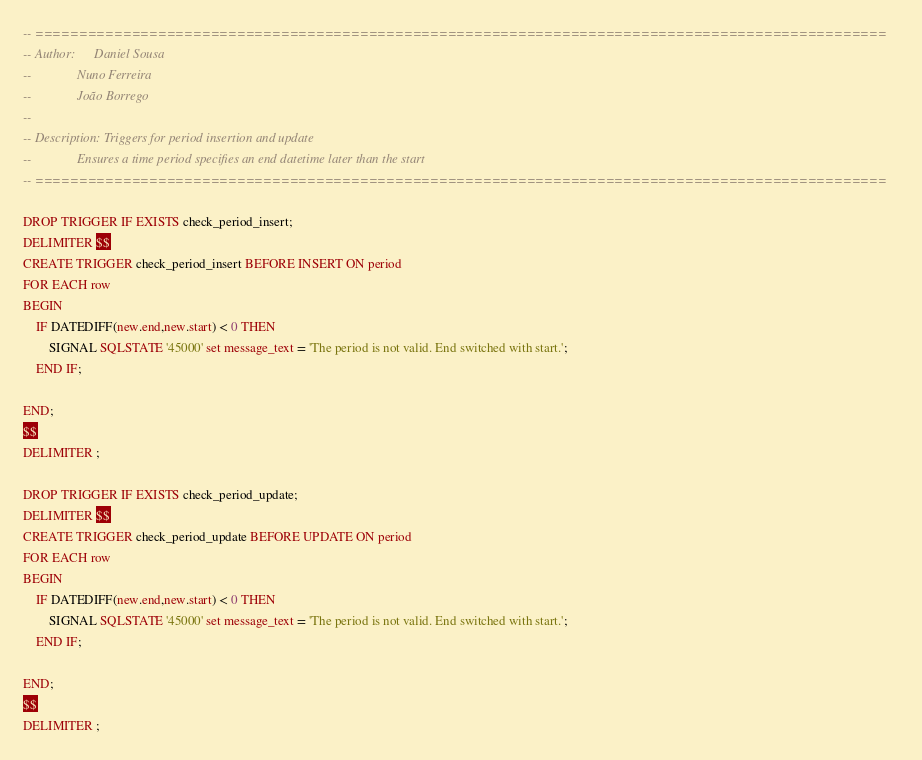<code> <loc_0><loc_0><loc_500><loc_500><_SQL_>-- =================================================================================================
-- Author:      Daniel Sousa
--              Nuno Ferreira
--              João Borrego
--
-- Description: Triggers for period insertion and update
--              Ensures a time period specifies an end datetime later than the start
-- =================================================================================================

DROP TRIGGER IF EXISTS check_period_insert;
DELIMITER $$
CREATE TRIGGER check_period_insert BEFORE INSERT ON period
FOR EACH row
BEGIN 
    IF DATEDIFF(new.end,new.start) < 0 THEN
        SIGNAL SQLSTATE '45000' set message_text = 'The period is not valid. End switched with start.';
    END IF;  

END;
$$
DELIMITER ;

DROP TRIGGER IF EXISTS check_period_update;
DELIMITER $$
CREATE TRIGGER check_period_update BEFORE UPDATE ON period
FOR EACH row
BEGIN 
    IF DATEDIFF(new.end,new.start) < 0 THEN 
        SIGNAL SQLSTATE '45000' set message_text = 'The period is not valid. End switched with start.';
    END IF;  

END;
$$
DELIMITER ;</code> 